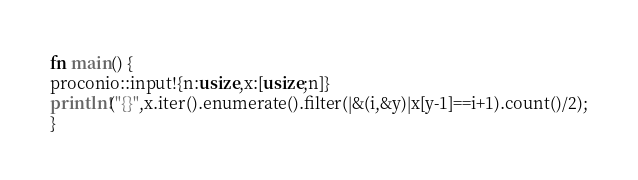Convert code to text. <code><loc_0><loc_0><loc_500><loc_500><_Rust_>fn main() {
proconio::input!{n:usize,x:[usize;n]}
println!("{}",x.iter().enumerate().filter(|&(i,&y)|x[y-1]==i+1).count()/2);
}</code> 